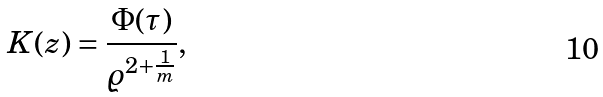<formula> <loc_0><loc_0><loc_500><loc_500>K ( z ) = \frac { \Phi ( \tau ) } { \varrho ^ { 2 + \frac { 1 } { m } } } ,</formula> 